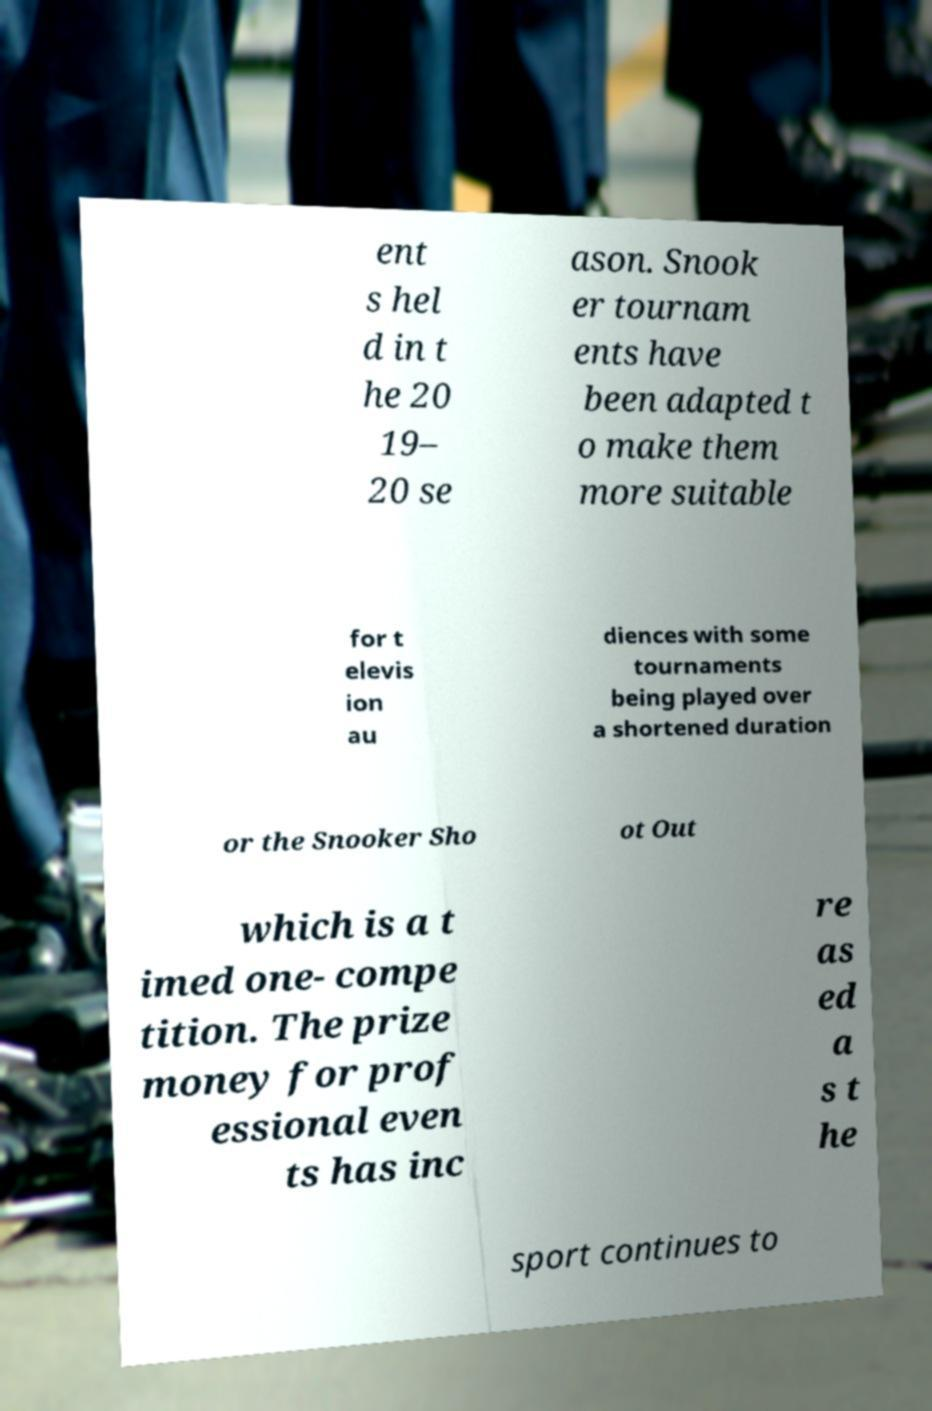What messages or text are displayed in this image? I need them in a readable, typed format. ent s hel d in t he 20 19– 20 se ason. Snook er tournam ents have been adapted t o make them more suitable for t elevis ion au diences with some tournaments being played over a shortened duration or the Snooker Sho ot Out which is a t imed one- compe tition. The prize money for prof essional even ts has inc re as ed a s t he sport continues to 